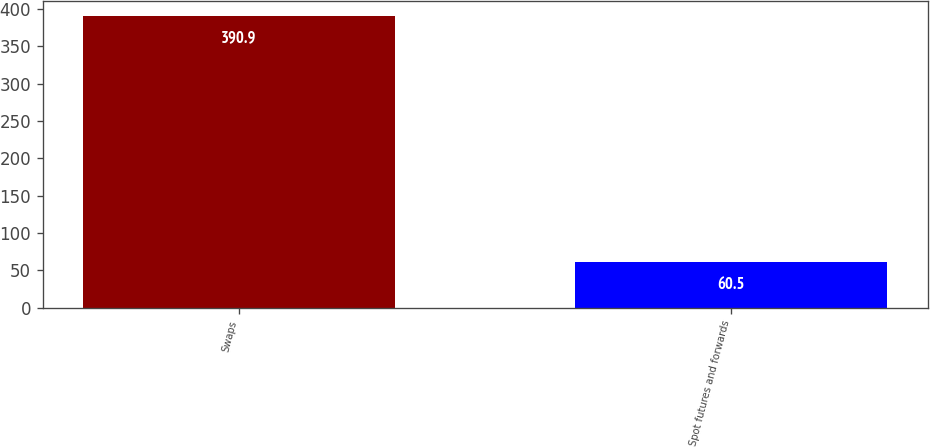<chart> <loc_0><loc_0><loc_500><loc_500><bar_chart><fcel>Swaps<fcel>Spot futures and forwards<nl><fcel>390.9<fcel>60.5<nl></chart> 